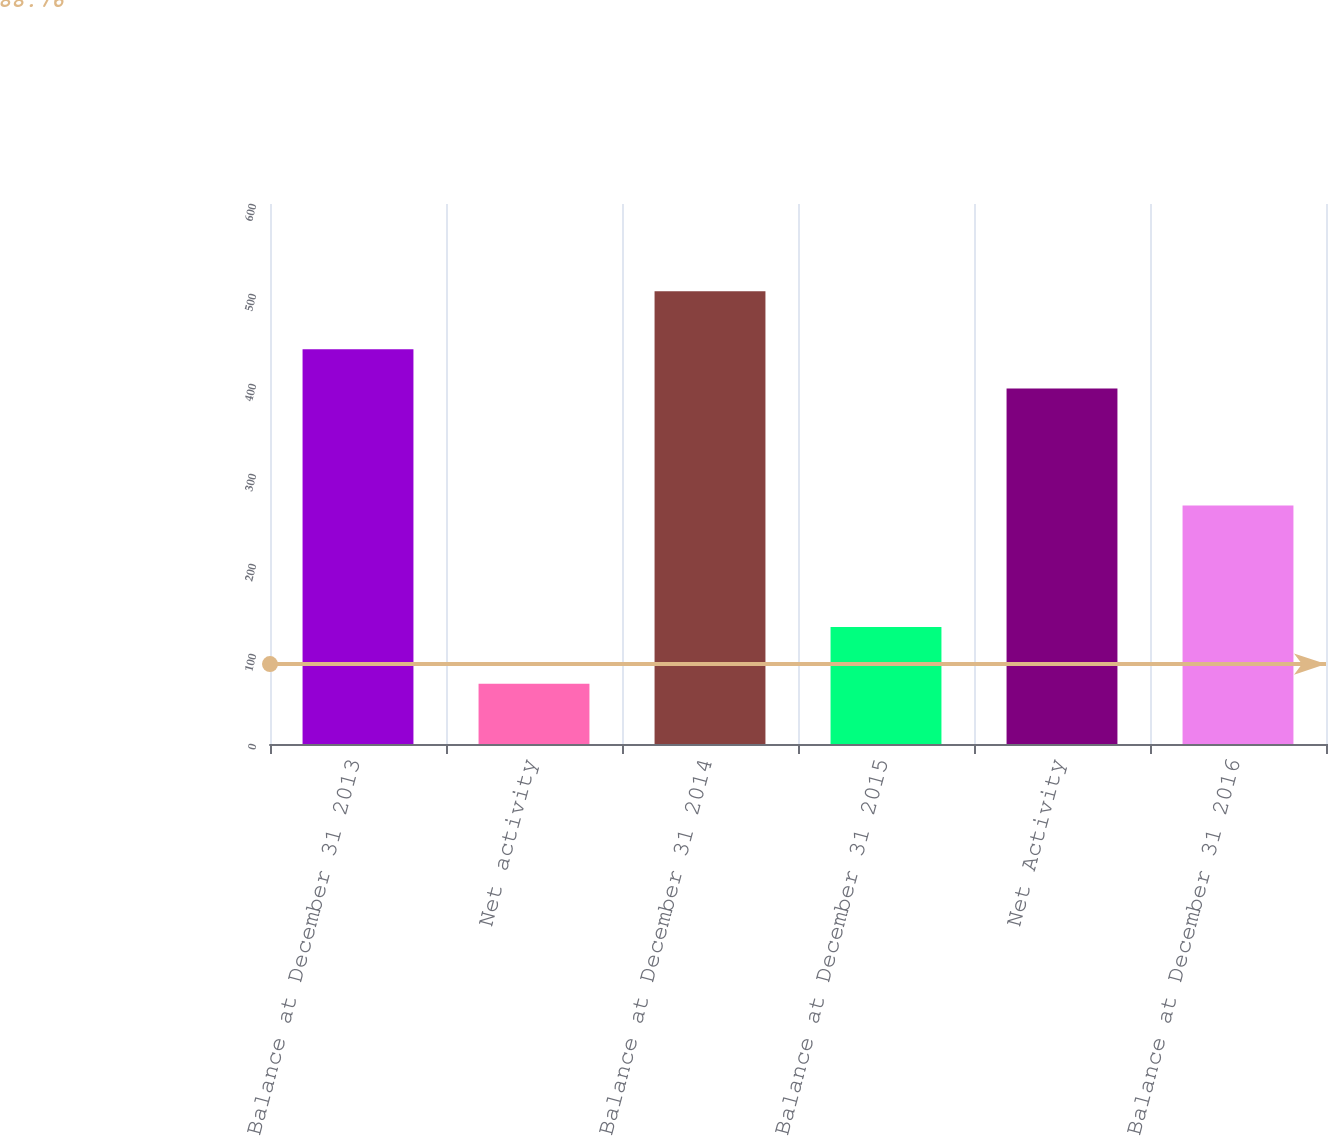Convert chart to OTSL. <chart><loc_0><loc_0><loc_500><loc_500><bar_chart><fcel>Balance at December 31 2013<fcel>Net activity<fcel>Balance at December 31 2014<fcel>Balance at December 31 2015<fcel>Net Activity<fcel>Balance at December 31 2016<nl><fcel>438.6<fcel>67<fcel>503<fcel>130<fcel>395<fcel>265<nl></chart> 